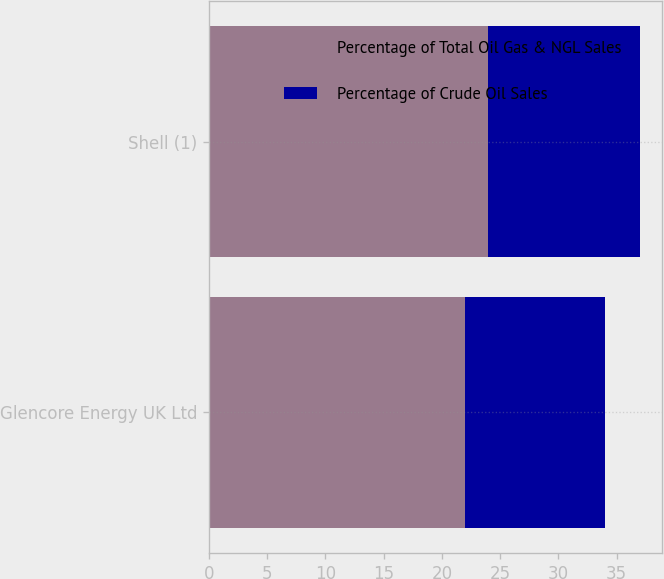Convert chart to OTSL. <chart><loc_0><loc_0><loc_500><loc_500><stacked_bar_chart><ecel><fcel>Glencore Energy UK Ltd<fcel>Shell (1)<nl><fcel>Percentage of Total Oil Gas & NGL Sales<fcel>22<fcel>24<nl><fcel>Percentage of Crude Oil Sales<fcel>12<fcel>13<nl></chart> 